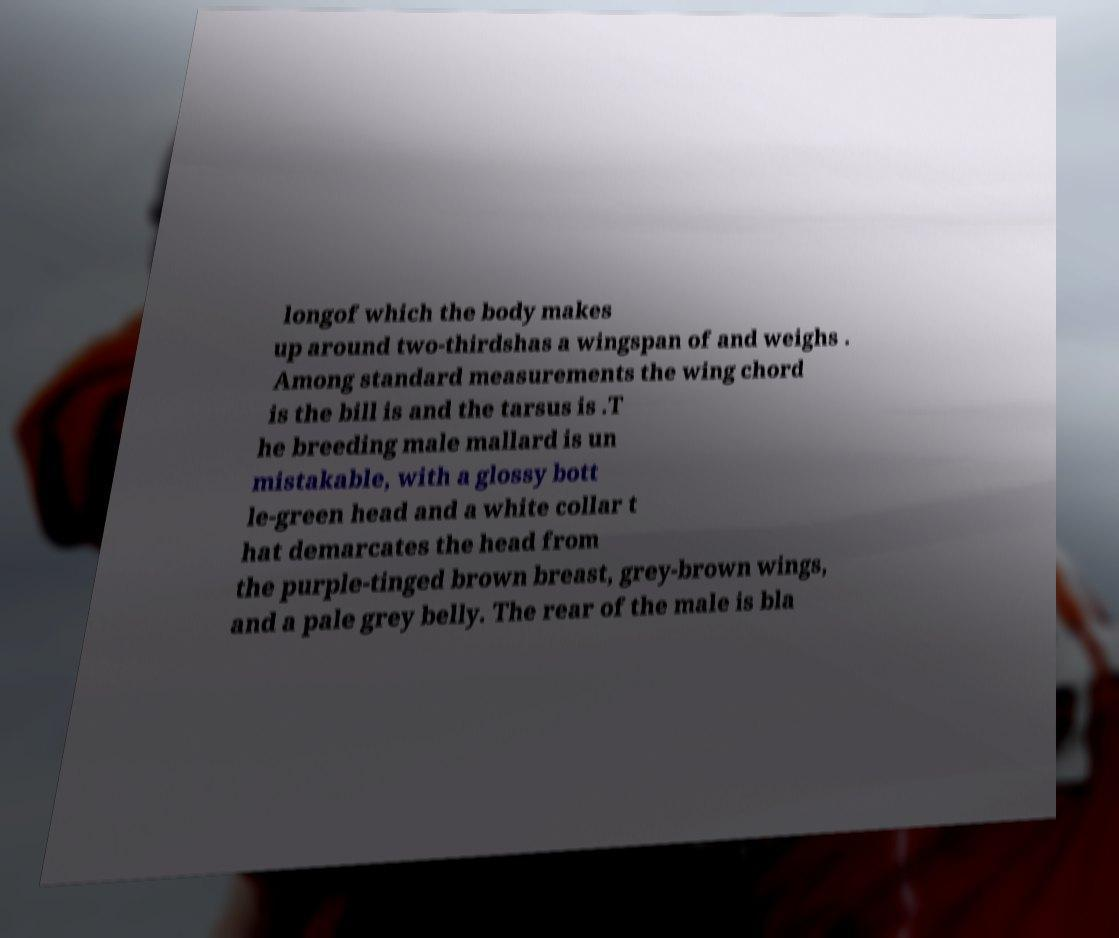Could you assist in decoding the text presented in this image and type it out clearly? longof which the body makes up around two-thirdshas a wingspan of and weighs . Among standard measurements the wing chord is the bill is and the tarsus is .T he breeding male mallard is un mistakable, with a glossy bott le-green head and a white collar t hat demarcates the head from the purple-tinged brown breast, grey-brown wings, and a pale grey belly. The rear of the male is bla 